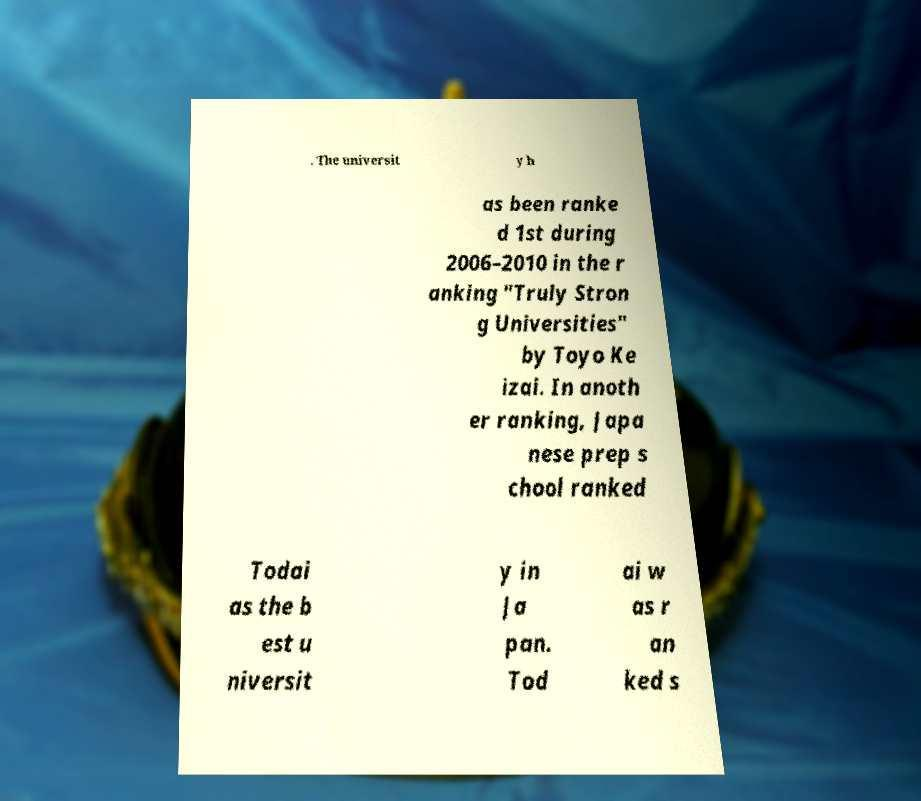Please read and relay the text visible in this image. What does it say? . The universit y h as been ranke d 1st during 2006–2010 in the r anking "Truly Stron g Universities" by Toyo Ke izai. In anoth er ranking, Japa nese prep s chool ranked Todai as the b est u niversit y in Ja pan. Tod ai w as r an ked s 